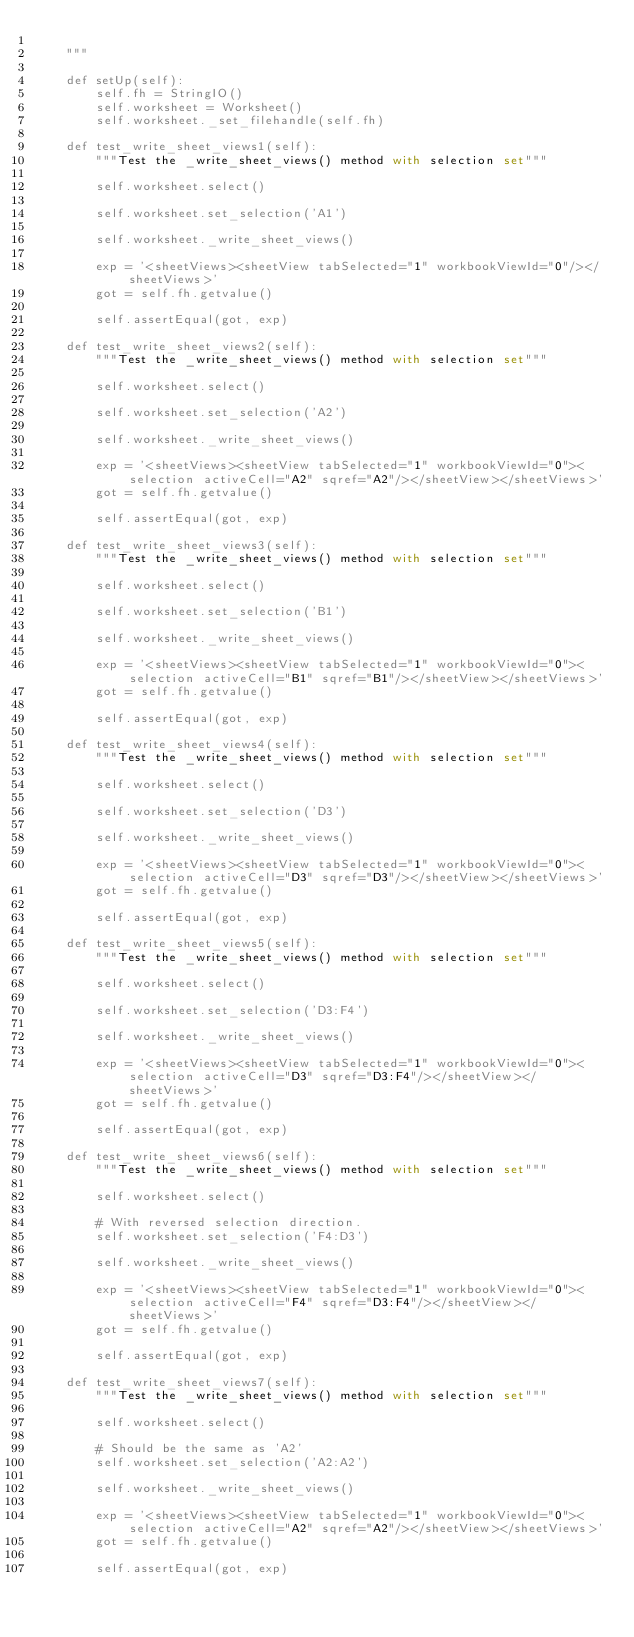Convert code to text. <code><loc_0><loc_0><loc_500><loc_500><_Python_>
    """

    def setUp(self):
        self.fh = StringIO()
        self.worksheet = Worksheet()
        self.worksheet._set_filehandle(self.fh)

    def test_write_sheet_views1(self):
        """Test the _write_sheet_views() method with selection set"""

        self.worksheet.select()

        self.worksheet.set_selection('A1')

        self.worksheet._write_sheet_views()

        exp = '<sheetViews><sheetView tabSelected="1" workbookViewId="0"/></sheetViews>'
        got = self.fh.getvalue()

        self.assertEqual(got, exp)

    def test_write_sheet_views2(self):
        """Test the _write_sheet_views() method with selection set"""

        self.worksheet.select()

        self.worksheet.set_selection('A2')

        self.worksheet._write_sheet_views()

        exp = '<sheetViews><sheetView tabSelected="1" workbookViewId="0"><selection activeCell="A2" sqref="A2"/></sheetView></sheetViews>'
        got = self.fh.getvalue()

        self.assertEqual(got, exp)

    def test_write_sheet_views3(self):
        """Test the _write_sheet_views() method with selection set"""

        self.worksheet.select()

        self.worksheet.set_selection('B1')

        self.worksheet._write_sheet_views()

        exp = '<sheetViews><sheetView tabSelected="1" workbookViewId="0"><selection activeCell="B1" sqref="B1"/></sheetView></sheetViews>'
        got = self.fh.getvalue()

        self.assertEqual(got, exp)

    def test_write_sheet_views4(self):
        """Test the _write_sheet_views() method with selection set"""

        self.worksheet.select()

        self.worksheet.set_selection('D3')

        self.worksheet._write_sheet_views()

        exp = '<sheetViews><sheetView tabSelected="1" workbookViewId="0"><selection activeCell="D3" sqref="D3"/></sheetView></sheetViews>'
        got = self.fh.getvalue()

        self.assertEqual(got, exp)

    def test_write_sheet_views5(self):
        """Test the _write_sheet_views() method with selection set"""

        self.worksheet.select()

        self.worksheet.set_selection('D3:F4')

        self.worksheet._write_sheet_views()

        exp = '<sheetViews><sheetView tabSelected="1" workbookViewId="0"><selection activeCell="D3" sqref="D3:F4"/></sheetView></sheetViews>'
        got = self.fh.getvalue()

        self.assertEqual(got, exp)

    def test_write_sheet_views6(self):
        """Test the _write_sheet_views() method with selection set"""

        self.worksheet.select()

        # With reversed selection direction.
        self.worksheet.set_selection('F4:D3')

        self.worksheet._write_sheet_views()

        exp = '<sheetViews><sheetView tabSelected="1" workbookViewId="0"><selection activeCell="F4" sqref="D3:F4"/></sheetView></sheetViews>'
        got = self.fh.getvalue()

        self.assertEqual(got, exp)

    def test_write_sheet_views7(self):
        """Test the _write_sheet_views() method with selection set"""

        self.worksheet.select()

        # Should be the same as 'A2'
        self.worksheet.set_selection('A2:A2')

        self.worksheet._write_sheet_views()

        exp = '<sheetViews><sheetView tabSelected="1" workbookViewId="0"><selection activeCell="A2" sqref="A2"/></sheetView></sheetViews>'
        got = self.fh.getvalue()

        self.assertEqual(got, exp)
</code> 